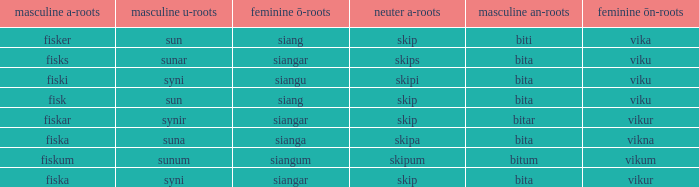What is the masculine an form for the word with a feminine ö ending of siangar and a masculine u ending of sunar? Bita. 